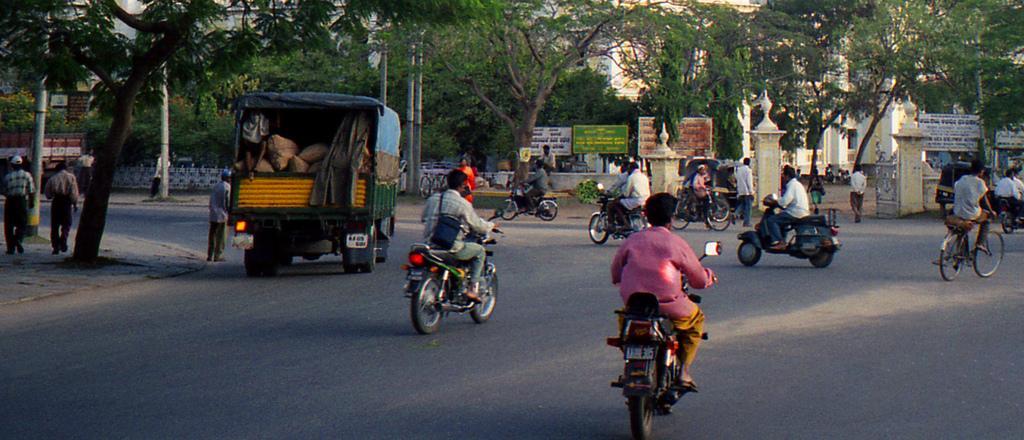How would you summarize this image in a sentence or two? Some bikes and few vehicles are passing on a road. Some people are walking by the side of the road. 